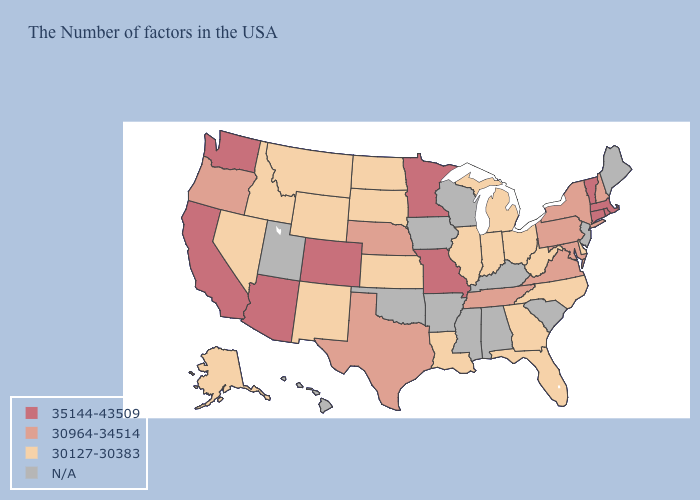Which states have the lowest value in the USA?
Concise answer only. Delaware, North Carolina, West Virginia, Ohio, Florida, Georgia, Michigan, Indiana, Illinois, Louisiana, Kansas, South Dakota, North Dakota, Wyoming, New Mexico, Montana, Idaho, Nevada, Alaska. Among the states that border Missouri , which have the lowest value?
Be succinct. Illinois, Kansas. Among the states that border Ohio , which have the highest value?
Be succinct. Pennsylvania. Does the map have missing data?
Give a very brief answer. Yes. Which states have the lowest value in the USA?
Be succinct. Delaware, North Carolina, West Virginia, Ohio, Florida, Georgia, Michigan, Indiana, Illinois, Louisiana, Kansas, South Dakota, North Dakota, Wyoming, New Mexico, Montana, Idaho, Nevada, Alaska. Is the legend a continuous bar?
Concise answer only. No. What is the value of Maryland?
Short answer required. 30964-34514. Among the states that border Mississippi , does Louisiana have the highest value?
Write a very short answer. No. Is the legend a continuous bar?
Be succinct. No. Name the states that have a value in the range 30964-34514?
Short answer required. New Hampshire, New York, Maryland, Pennsylvania, Virginia, Tennessee, Nebraska, Texas, Oregon. Is the legend a continuous bar?
Give a very brief answer. No. Name the states that have a value in the range N/A?
Keep it brief. Maine, New Jersey, South Carolina, Kentucky, Alabama, Wisconsin, Mississippi, Arkansas, Iowa, Oklahoma, Utah, Hawaii. What is the highest value in the USA?
Quick response, please. 35144-43509. What is the value of Massachusetts?
Short answer required. 35144-43509. 